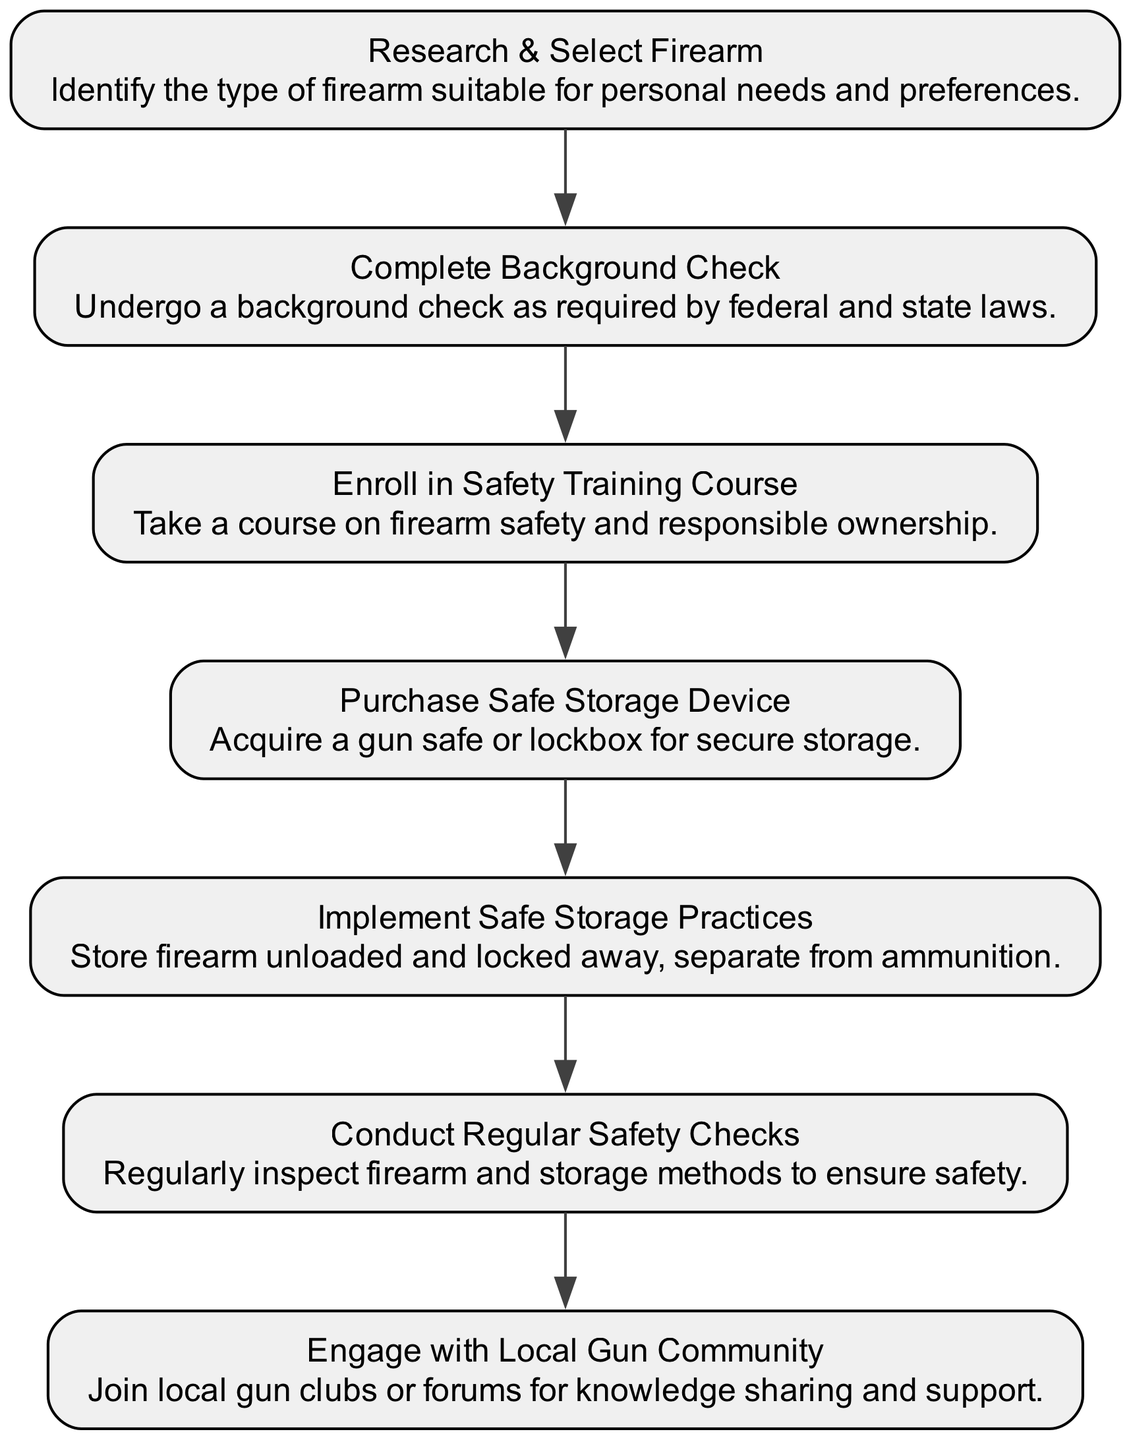What is the first step a new gun owner takes? The first step is "Research & Select Firearm", which indicates that the journey begins with identifying the type of firearm suitable for personal needs and preferences.
Answer: Research & Select Firearm How many nodes are present in the diagram? The diagram contains a total of 7 nodes representing different steps in the journey of a new gun owner. Counting all the unique elements listed confirms this.
Answer: 7 What step comes after purchasing a firearm? After "Research & Select Firearm", the next step is "Complete Background Check". This indicates that a background check is necessary immediately after selecting a firearm.
Answer: Complete Background Check What do new gun owners need to do after completing a background check? Once the background check is completed, the next action is to "Enroll in Safety Training Course", which emphasizes the importance of safety training for new gun owners.
Answer: Enroll in Safety Training Course What is the relationship between "Engage with Local Gun Community" and "Conduct Regular Safety Checks"? "Engage with Local Gun Community" is the last step in the flow, suggesting that new gun owners should join local clubs or forums for ongoing support after conducting regular safety checks. This illustrates the idea of continuous engagement and networking in the gun community after ensuring safety practices.
Answer: No direct relationship What is the last step new gun owners should take? The diagram indicates that "Engage with Local Gun Community" is the last step, emphasizing the importance of connecting with others for support and knowledge sharing in the gun ownership journey.
Answer: Engage with Local Gun Community Which step involves acquiring a safe storage device? The step "Purchase Safe Storage Device" directly indicates that new gun owners need to acquire a gun safe or lockbox for secure storage of their firearm after completing the necessary safety training.
Answer: Purchase Safe Storage Device What do the storage practices entail according to the diagram? The node labeled "Implement Safe Storage Practices" describes that firearms should be stored unloaded and locked away, separate from ammunition, ensuring safety in storage practices.
Answer: Store firearm unloaded and locked away, separate from ammunition 